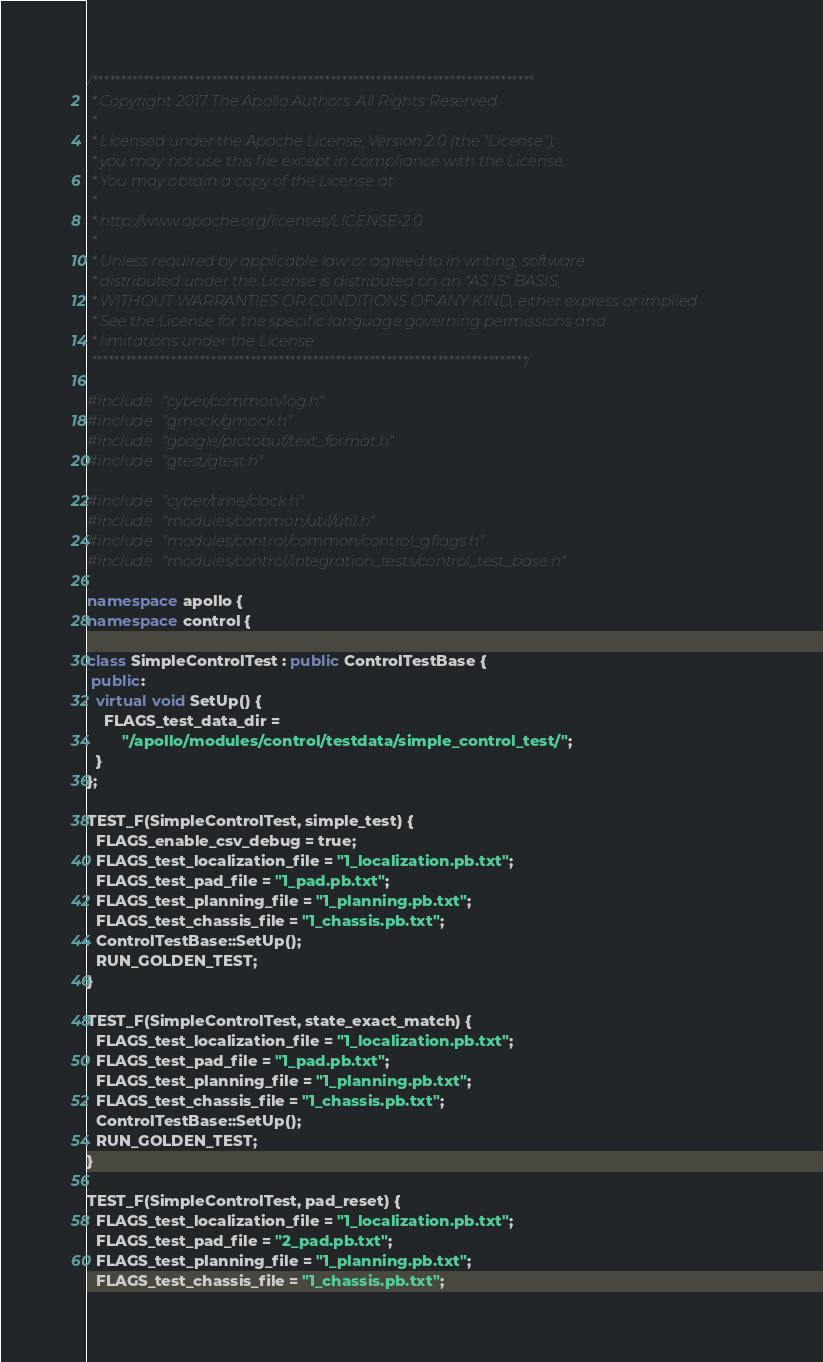<code> <loc_0><loc_0><loc_500><loc_500><_C++_>/******************************************************************************
 * Copyright 2017 The Apollo Authors. All Rights Reserved.
 *
 * Licensed under the Apache License, Version 2.0 (the "License");
 * you may not use this file except in compliance with the License.
 * You may obtain a copy of the License at
 *
 * http://www.apache.org/licenses/LICENSE-2.0
 *
 * Unless required by applicable law or agreed to in writing, software
 * distributed under the License is distributed on an "AS IS" BASIS,
 * WITHOUT WARRANTIES OR CONDITIONS OF ANY KIND, either express or implied.
 * See the License for the specific language governing permissions and
 * limitations under the License.
 *****************************************************************************/

#include "cyber/common/log.h"
#include "gmock/gmock.h"
#include "google/protobuf/text_format.h"
#include "gtest/gtest.h"

#include "cyber/time/clock.h"
#include "modules/common/util/util.h"
#include "modules/control/common/control_gflags.h"
#include "modules/control/integration_tests/control_test_base.h"

namespace apollo {
namespace control {

class SimpleControlTest : public ControlTestBase {
 public:
  virtual void SetUp() {
    FLAGS_test_data_dir =
        "/apollo/modules/control/testdata/simple_control_test/";
  }
};

TEST_F(SimpleControlTest, simple_test) {
  FLAGS_enable_csv_debug = true;
  FLAGS_test_localization_file = "1_localization.pb.txt";
  FLAGS_test_pad_file = "1_pad.pb.txt";
  FLAGS_test_planning_file = "1_planning.pb.txt";
  FLAGS_test_chassis_file = "1_chassis.pb.txt";
  ControlTestBase::SetUp();
  RUN_GOLDEN_TEST;
}

TEST_F(SimpleControlTest, state_exact_match) {
  FLAGS_test_localization_file = "1_localization.pb.txt";
  FLAGS_test_pad_file = "1_pad.pb.txt";
  FLAGS_test_planning_file = "1_planning.pb.txt";
  FLAGS_test_chassis_file = "1_chassis.pb.txt";
  ControlTestBase::SetUp();
  RUN_GOLDEN_TEST;
}

TEST_F(SimpleControlTest, pad_reset) {
  FLAGS_test_localization_file = "1_localization.pb.txt";
  FLAGS_test_pad_file = "2_pad.pb.txt";
  FLAGS_test_planning_file = "1_planning.pb.txt";
  FLAGS_test_chassis_file = "1_chassis.pb.txt";</code> 